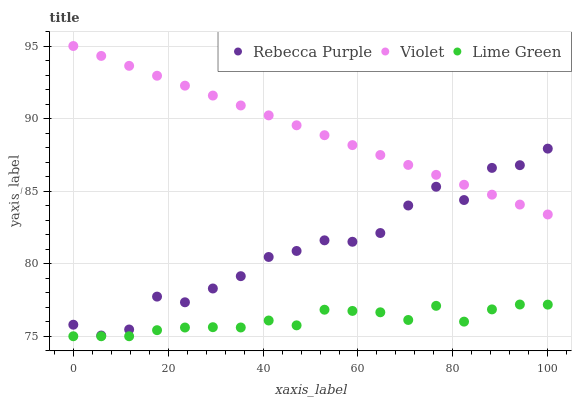Does Lime Green have the minimum area under the curve?
Answer yes or no. Yes. Does Violet have the maximum area under the curve?
Answer yes or no. Yes. Does Rebecca Purple have the minimum area under the curve?
Answer yes or no. No. Does Rebecca Purple have the maximum area under the curve?
Answer yes or no. No. Is Violet the smoothest?
Answer yes or no. Yes. Is Rebecca Purple the roughest?
Answer yes or no. Yes. Is Rebecca Purple the smoothest?
Answer yes or no. No. Is Violet the roughest?
Answer yes or no. No. Does Lime Green have the lowest value?
Answer yes or no. Yes. Does Rebecca Purple have the lowest value?
Answer yes or no. No. Does Violet have the highest value?
Answer yes or no. Yes. Does Rebecca Purple have the highest value?
Answer yes or no. No. Is Lime Green less than Rebecca Purple?
Answer yes or no. Yes. Is Rebecca Purple greater than Lime Green?
Answer yes or no. Yes. Does Rebecca Purple intersect Violet?
Answer yes or no. Yes. Is Rebecca Purple less than Violet?
Answer yes or no. No. Is Rebecca Purple greater than Violet?
Answer yes or no. No. Does Lime Green intersect Rebecca Purple?
Answer yes or no. No. 